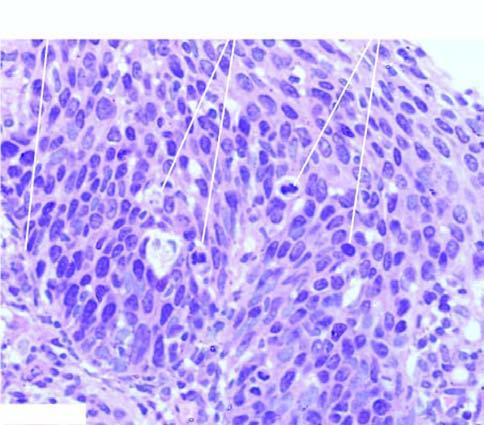what are the atypical dysplastic squamous cells confined to?
Answer the question using a single word or phrase. All the layers of the mucosa 